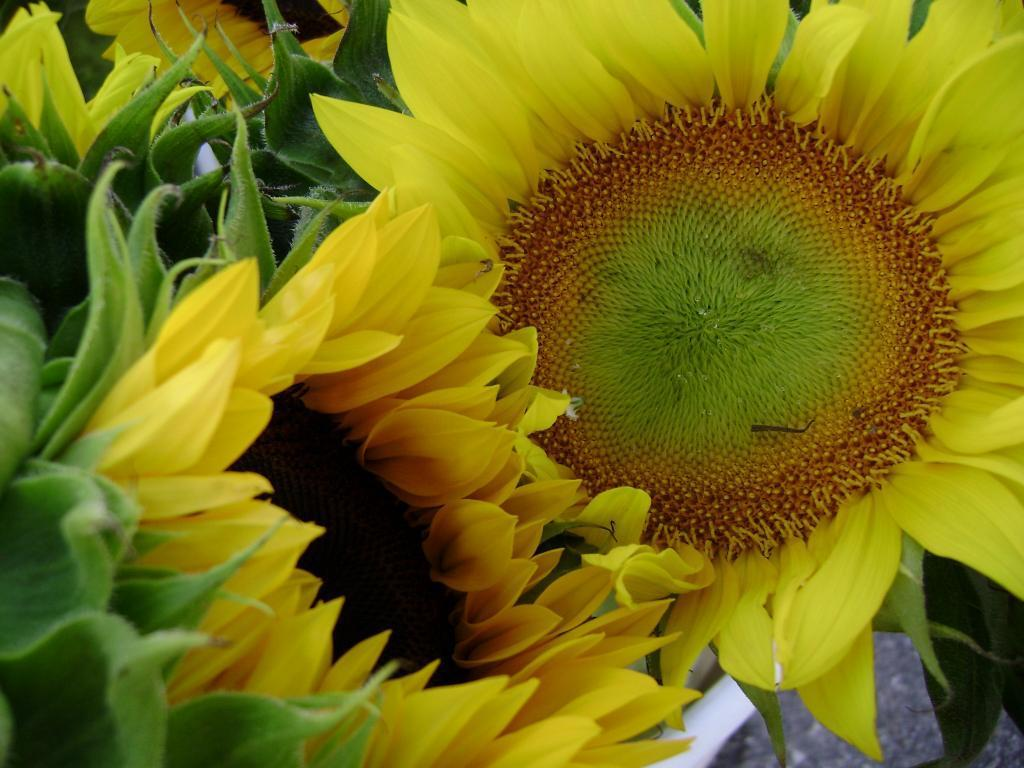What type of flowers are in the image? There are sunflowers in the image. What color are the sunflowers? The sunflowers are yellow. What part of the sunflowers is green? There are green sepals in the image. What other flowers can be seen in the background of the image? There are flowers in the background of the image, and they are also yellow. How does the pear's hair look in the image? There is no pear or hair present in the image. What type of spark can be seen coming from the flowers in the image? There is no spark present in the image; it features sunflowers and other flowers without any spark. 